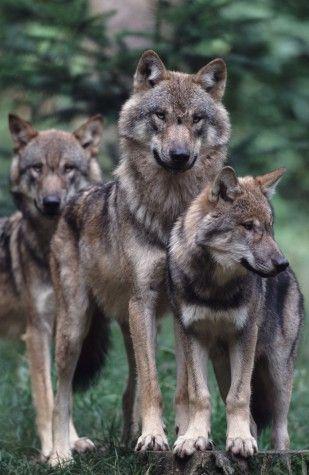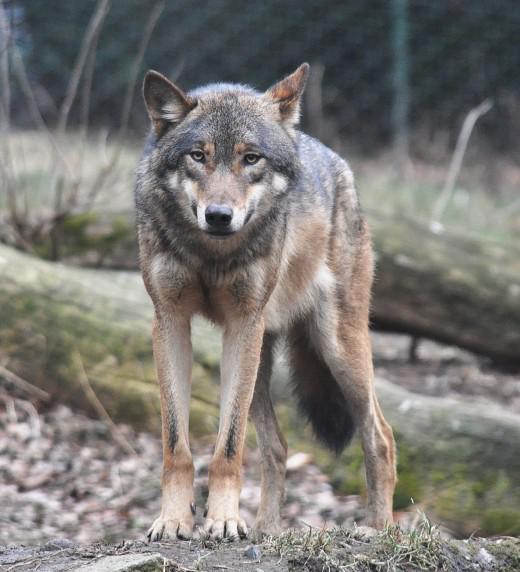The first image is the image on the left, the second image is the image on the right. For the images displayed, is the sentence "One image contains more than one wolf, and one image contains a single wolf, who is standing on all fours." factually correct? Answer yes or no. Yes. 